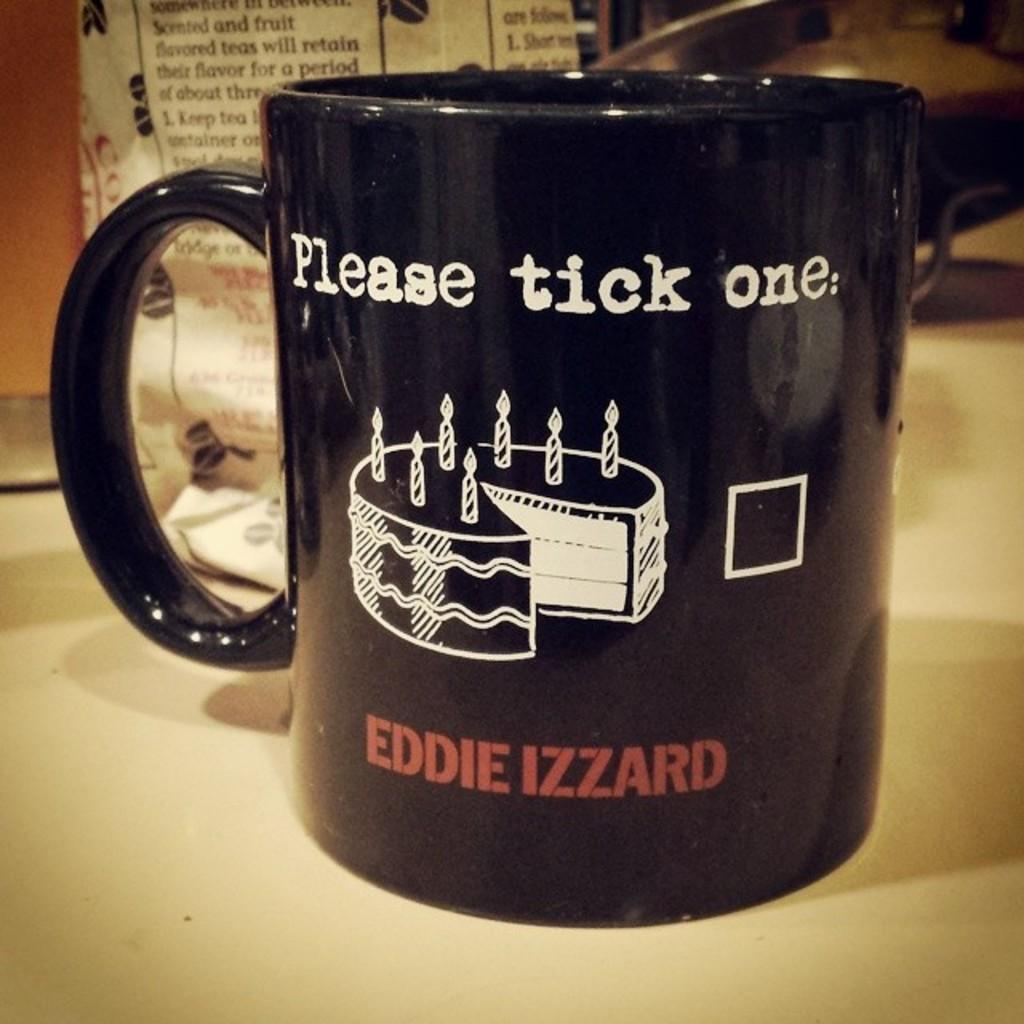<image>
Offer a succinct explanation of the picture presented. a black coffee cup with a cake for eddie izzard 